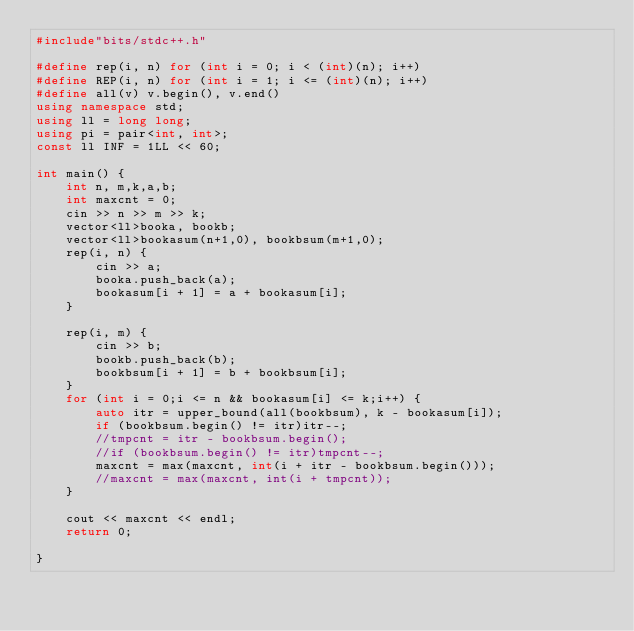Convert code to text. <code><loc_0><loc_0><loc_500><loc_500><_C++_>#include"bits/stdc++.h"

#define rep(i, n) for (int i = 0; i < (int)(n); i++)
#define REP(i, n) for (int i = 1; i <= (int)(n); i++)
#define all(v) v.begin(), v.end()
using namespace std;
using ll = long long;
using pi = pair<int, int>;
const ll INF = 1LL << 60;

int main() {
    int n, m,k,a,b;
    int maxcnt = 0;
    cin >> n >> m >> k;
    vector<ll>booka, bookb;
    vector<ll>bookasum(n+1,0), bookbsum(m+1,0);
    rep(i, n) {
        cin >> a;
        booka.push_back(a);
        bookasum[i + 1] = a + bookasum[i];
    }

    rep(i, m) {
        cin >> b;
        bookb.push_back(b);
        bookbsum[i + 1] = b + bookbsum[i];
    }
    for (int i = 0;i <= n && bookasum[i] <= k;i++) {
        auto itr = upper_bound(all(bookbsum), k - bookasum[i]);
        if (bookbsum.begin() != itr)itr--;
        //tmpcnt = itr - bookbsum.begin();
        //if (bookbsum.begin() != itr)tmpcnt--;
        maxcnt = max(maxcnt, int(i + itr - bookbsum.begin()));
        //maxcnt = max(maxcnt, int(i + tmpcnt));
    }

    cout << maxcnt << endl;
    return 0;

}
</code> 